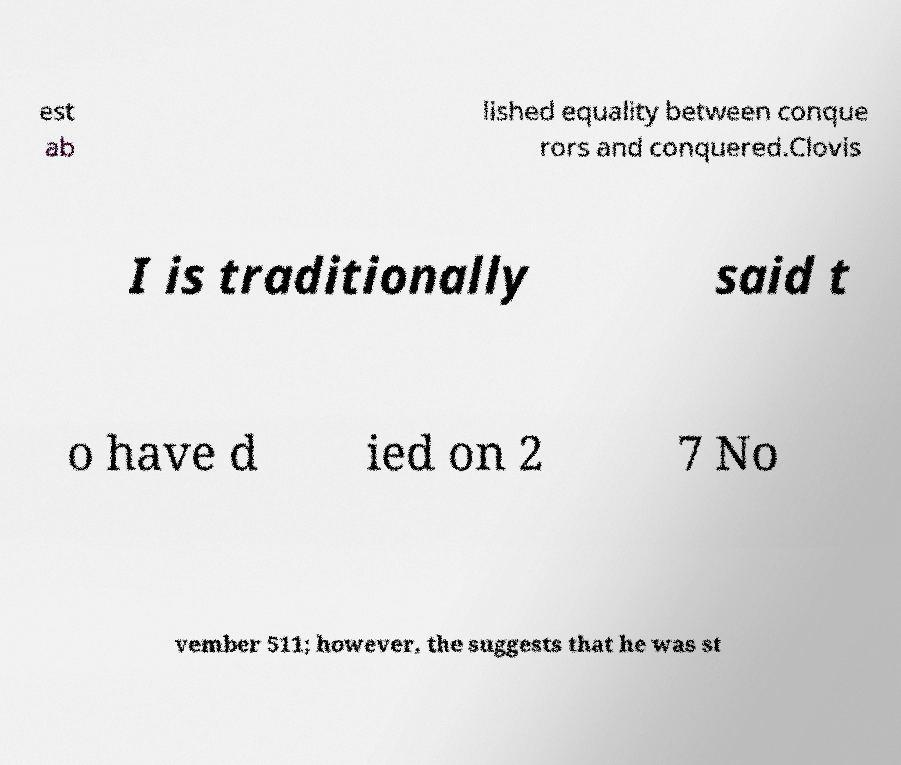I need the written content from this picture converted into text. Can you do that? est ab lished equality between conque rors and conquered.Clovis I is traditionally said t o have d ied on 2 7 No vember 511; however, the suggests that he was st 